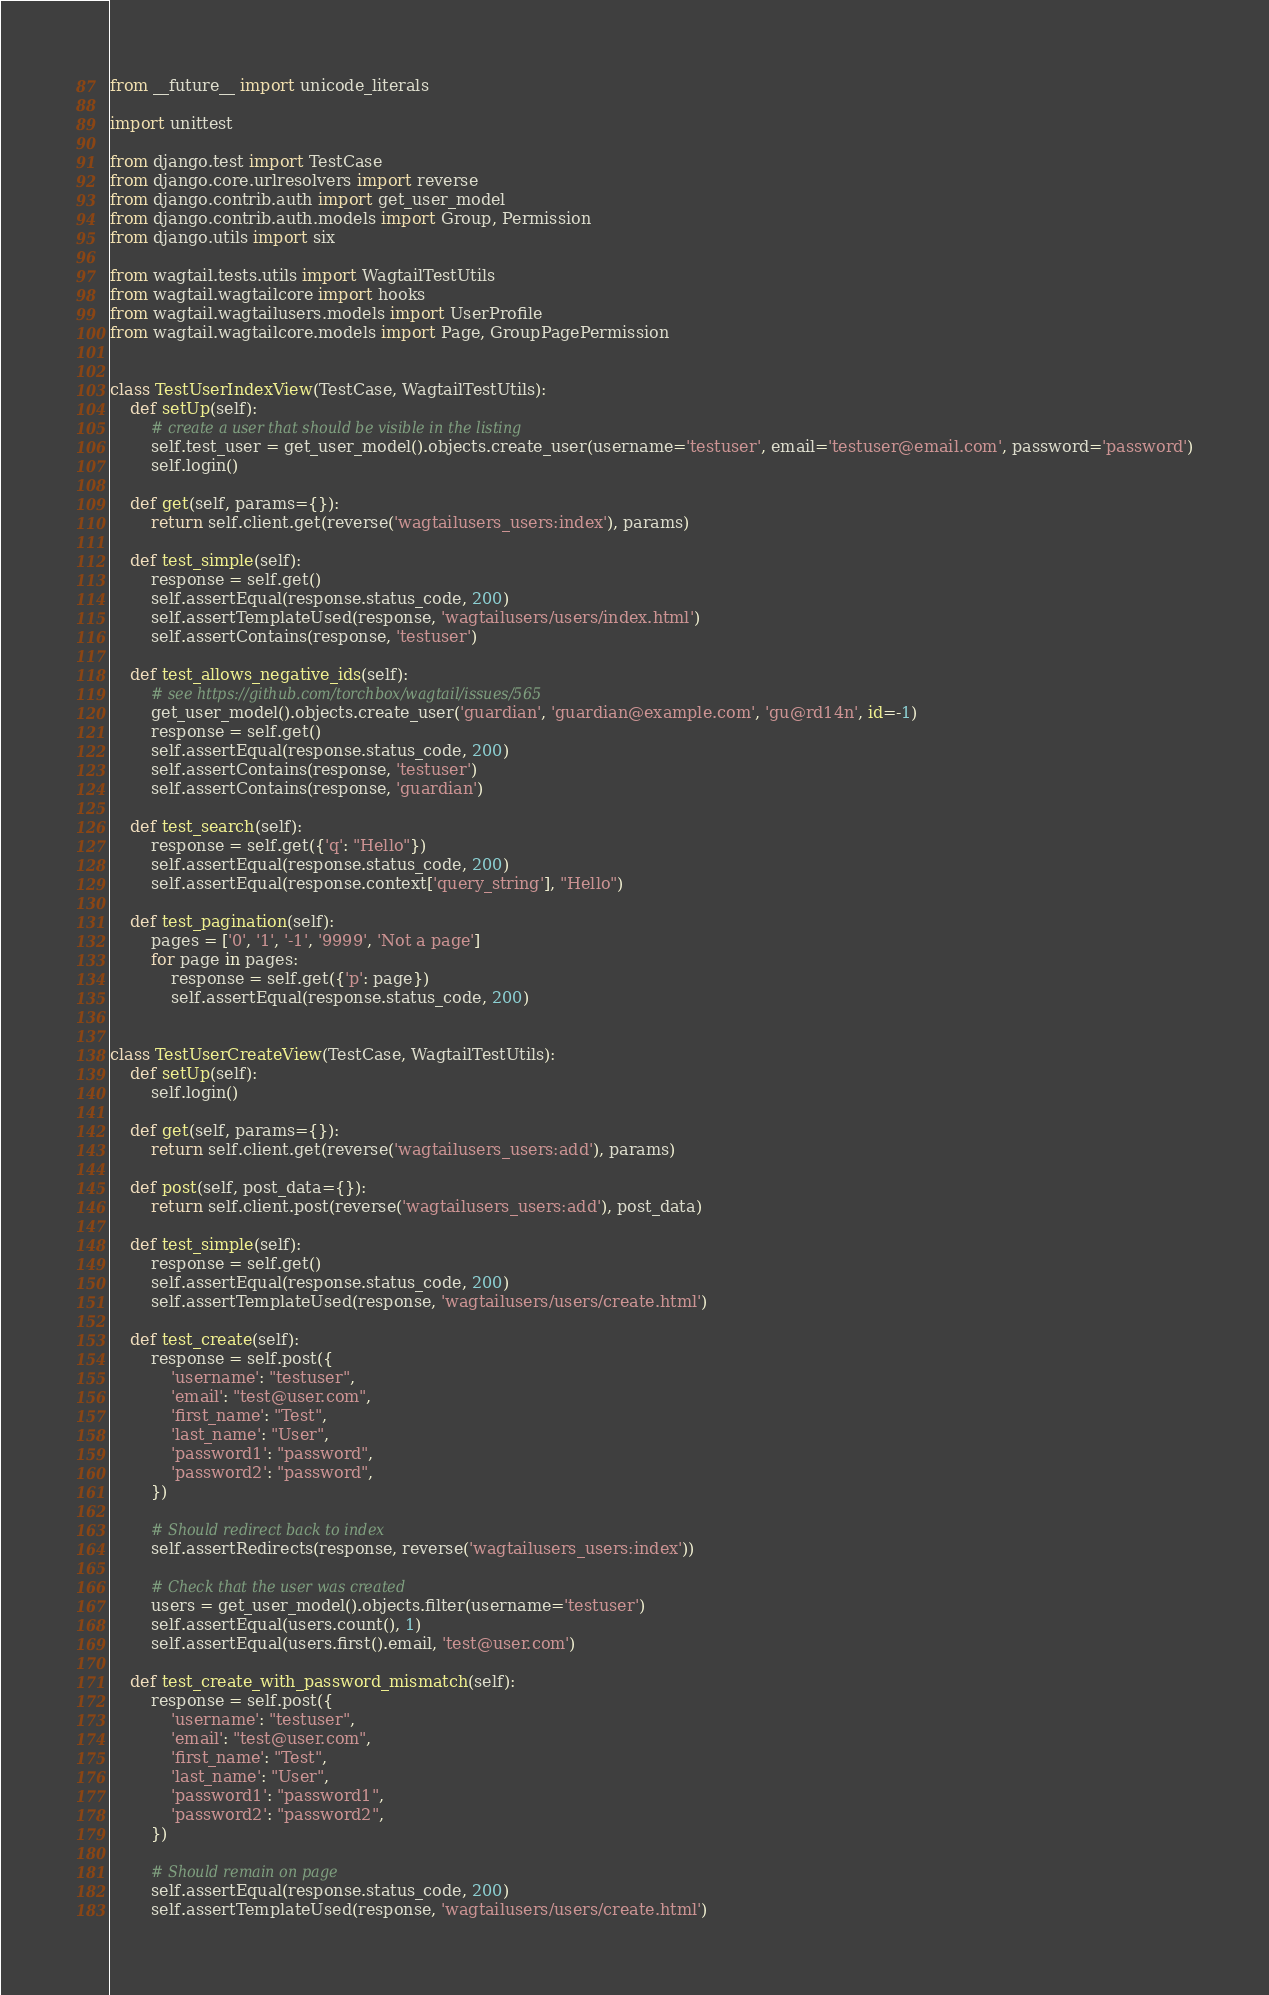Convert code to text. <code><loc_0><loc_0><loc_500><loc_500><_Python_>from __future__ import unicode_literals

import unittest

from django.test import TestCase
from django.core.urlresolvers import reverse
from django.contrib.auth import get_user_model
from django.contrib.auth.models import Group, Permission
from django.utils import six

from wagtail.tests.utils import WagtailTestUtils
from wagtail.wagtailcore import hooks
from wagtail.wagtailusers.models import UserProfile
from wagtail.wagtailcore.models import Page, GroupPagePermission


class TestUserIndexView(TestCase, WagtailTestUtils):
    def setUp(self):
        # create a user that should be visible in the listing
        self.test_user = get_user_model().objects.create_user(username='testuser', email='testuser@email.com', password='password')
        self.login()

    def get(self, params={}):
        return self.client.get(reverse('wagtailusers_users:index'), params)

    def test_simple(self):
        response = self.get()
        self.assertEqual(response.status_code, 200)
        self.assertTemplateUsed(response, 'wagtailusers/users/index.html')
        self.assertContains(response, 'testuser')

    def test_allows_negative_ids(self):
        # see https://github.com/torchbox/wagtail/issues/565
        get_user_model().objects.create_user('guardian', 'guardian@example.com', 'gu@rd14n', id=-1)
        response = self.get()
        self.assertEqual(response.status_code, 200)
        self.assertContains(response, 'testuser')
        self.assertContains(response, 'guardian')

    def test_search(self):
        response = self.get({'q': "Hello"})
        self.assertEqual(response.status_code, 200)
        self.assertEqual(response.context['query_string'], "Hello")

    def test_pagination(self):
        pages = ['0', '1', '-1', '9999', 'Not a page']
        for page in pages:
            response = self.get({'p': page})
            self.assertEqual(response.status_code, 200)


class TestUserCreateView(TestCase, WagtailTestUtils):
    def setUp(self):
        self.login()

    def get(self, params={}):
        return self.client.get(reverse('wagtailusers_users:add'), params)

    def post(self, post_data={}):
        return self.client.post(reverse('wagtailusers_users:add'), post_data)

    def test_simple(self):
        response = self.get()
        self.assertEqual(response.status_code, 200)
        self.assertTemplateUsed(response, 'wagtailusers/users/create.html')

    def test_create(self):
        response = self.post({
            'username': "testuser",
            'email': "test@user.com",
            'first_name': "Test",
            'last_name': "User",
            'password1': "password",
            'password2': "password",
        })

        # Should redirect back to index
        self.assertRedirects(response, reverse('wagtailusers_users:index'))

        # Check that the user was created
        users = get_user_model().objects.filter(username='testuser')
        self.assertEqual(users.count(), 1)
        self.assertEqual(users.first().email, 'test@user.com')

    def test_create_with_password_mismatch(self):
        response = self.post({
            'username': "testuser",
            'email': "test@user.com",
            'first_name': "Test",
            'last_name': "User",
            'password1': "password1",
            'password2': "password2",
        })

        # Should remain on page
        self.assertEqual(response.status_code, 200)
        self.assertTemplateUsed(response, 'wagtailusers/users/create.html')
</code> 